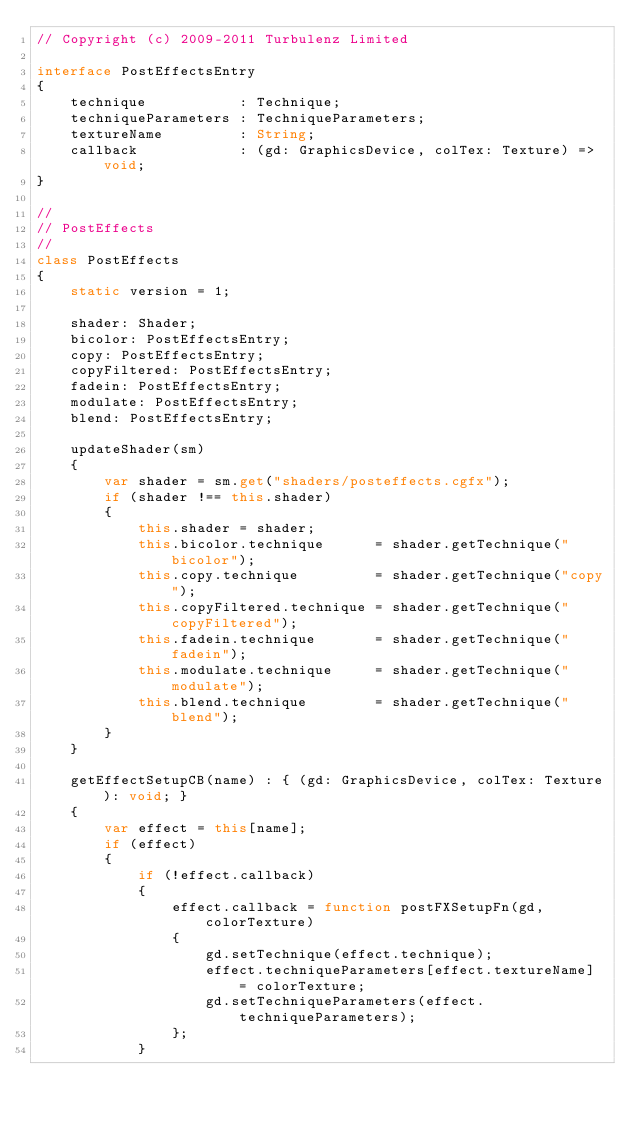Convert code to text. <code><loc_0><loc_0><loc_500><loc_500><_TypeScript_>// Copyright (c) 2009-2011 Turbulenz Limited

interface PostEffectsEntry
{
    technique           : Technique;
    techniqueParameters : TechniqueParameters;
    textureName         : String;
    callback            : (gd: GraphicsDevice, colTex: Texture) => void;
}

//
// PostEffects
//
class PostEffects
{
    static version = 1;

    shader: Shader;
    bicolor: PostEffectsEntry;
    copy: PostEffectsEntry;
    copyFiltered: PostEffectsEntry;
    fadein: PostEffectsEntry;
    modulate: PostEffectsEntry;
    blend: PostEffectsEntry;

    updateShader(sm)
    {
        var shader = sm.get("shaders/posteffects.cgfx");
        if (shader !== this.shader)
        {
            this.shader = shader;
            this.bicolor.technique      = shader.getTechnique("bicolor");
            this.copy.technique         = shader.getTechnique("copy");
            this.copyFiltered.technique = shader.getTechnique("copyFiltered");
            this.fadein.technique       = shader.getTechnique("fadein");
            this.modulate.technique     = shader.getTechnique("modulate");
            this.blend.technique        = shader.getTechnique("blend");
        }
    }

    getEffectSetupCB(name) : { (gd: GraphicsDevice, colTex: Texture): void; }
    {
        var effect = this[name];
        if (effect)
        {
            if (!effect.callback)
            {
                effect.callback = function postFXSetupFn(gd, colorTexture)
                {
                    gd.setTechnique(effect.technique);
                    effect.techniqueParameters[effect.textureName] = colorTexture;
                    gd.setTechniqueParameters(effect.techniqueParameters);
                };
            }</code> 